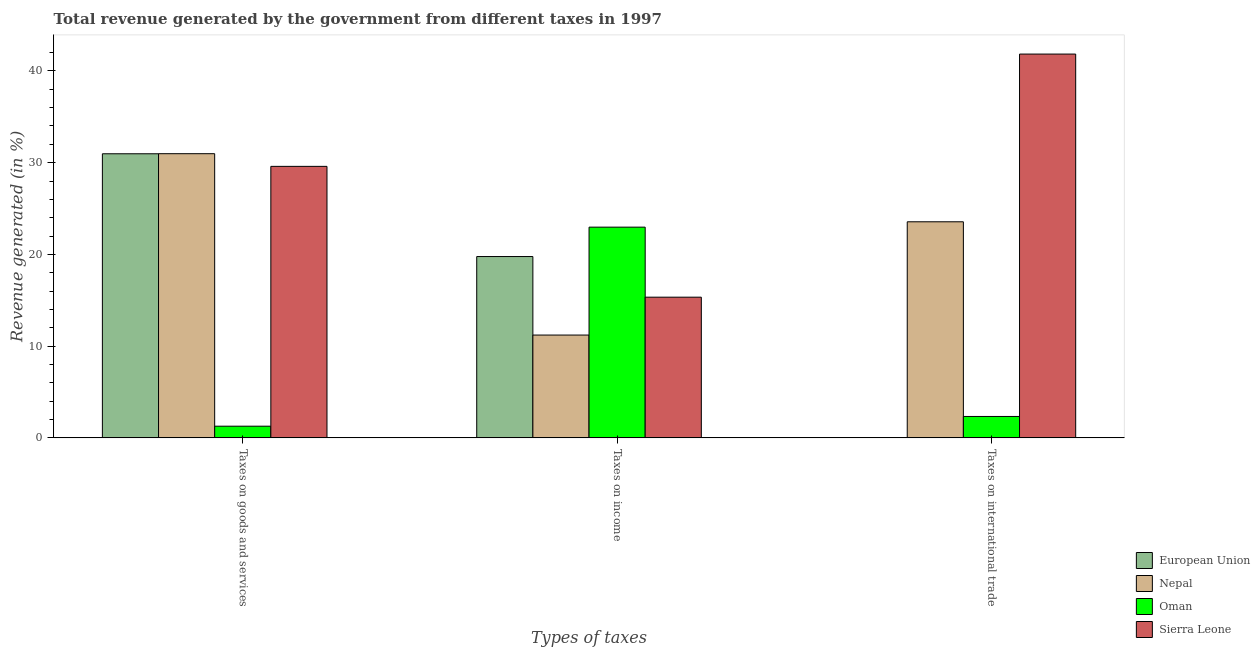How many bars are there on the 2nd tick from the left?
Keep it short and to the point. 4. What is the label of the 1st group of bars from the left?
Provide a short and direct response. Taxes on goods and services. What is the percentage of revenue generated by tax on international trade in Oman?
Make the answer very short. 2.33. Across all countries, what is the maximum percentage of revenue generated by tax on international trade?
Offer a terse response. 41.84. Across all countries, what is the minimum percentage of revenue generated by tax on international trade?
Your response must be concise. 0.02. In which country was the percentage of revenue generated by tax on international trade maximum?
Keep it short and to the point. Sierra Leone. In which country was the percentage of revenue generated by taxes on goods and services minimum?
Give a very brief answer. Oman. What is the total percentage of revenue generated by tax on international trade in the graph?
Ensure brevity in your answer.  67.74. What is the difference between the percentage of revenue generated by tax on international trade in Sierra Leone and that in Nepal?
Your response must be concise. 18.28. What is the difference between the percentage of revenue generated by taxes on income in Nepal and the percentage of revenue generated by tax on international trade in Oman?
Offer a very short reply. 8.87. What is the average percentage of revenue generated by tax on international trade per country?
Offer a very short reply. 16.94. What is the difference between the percentage of revenue generated by taxes on goods and services and percentage of revenue generated by tax on international trade in Sierra Leone?
Offer a terse response. -12.24. In how many countries, is the percentage of revenue generated by tax on international trade greater than 2 %?
Ensure brevity in your answer.  3. What is the ratio of the percentage of revenue generated by taxes on goods and services in Sierra Leone to that in Oman?
Give a very brief answer. 23.24. Is the percentage of revenue generated by taxes on income in Nepal less than that in Sierra Leone?
Provide a succinct answer. Yes. Is the difference between the percentage of revenue generated by tax on international trade in Sierra Leone and European Union greater than the difference between the percentage of revenue generated by taxes on income in Sierra Leone and European Union?
Offer a terse response. Yes. What is the difference between the highest and the second highest percentage of revenue generated by taxes on goods and services?
Offer a very short reply. 0.01. What is the difference between the highest and the lowest percentage of revenue generated by taxes on goods and services?
Keep it short and to the point. 29.7. In how many countries, is the percentage of revenue generated by taxes on goods and services greater than the average percentage of revenue generated by taxes on goods and services taken over all countries?
Your response must be concise. 3. Is the sum of the percentage of revenue generated by taxes on goods and services in Nepal and European Union greater than the maximum percentage of revenue generated by tax on international trade across all countries?
Offer a very short reply. Yes. What does the 4th bar from the left in Taxes on international trade represents?
Provide a short and direct response. Sierra Leone. What does the 1st bar from the right in Taxes on goods and services represents?
Your answer should be compact. Sierra Leone. How many bars are there?
Your response must be concise. 12. What is the difference between two consecutive major ticks on the Y-axis?
Make the answer very short. 10. Does the graph contain any zero values?
Give a very brief answer. No. Where does the legend appear in the graph?
Offer a terse response. Bottom right. How many legend labels are there?
Offer a terse response. 4. How are the legend labels stacked?
Your answer should be compact. Vertical. What is the title of the graph?
Make the answer very short. Total revenue generated by the government from different taxes in 1997. Does "Dominica" appear as one of the legend labels in the graph?
Offer a terse response. No. What is the label or title of the X-axis?
Your answer should be very brief. Types of taxes. What is the label or title of the Y-axis?
Make the answer very short. Revenue generated (in %). What is the Revenue generated (in %) in European Union in Taxes on goods and services?
Offer a terse response. 30.97. What is the Revenue generated (in %) in Nepal in Taxes on goods and services?
Offer a terse response. 30.98. What is the Revenue generated (in %) in Oman in Taxes on goods and services?
Your answer should be compact. 1.27. What is the Revenue generated (in %) of Sierra Leone in Taxes on goods and services?
Provide a succinct answer. 29.59. What is the Revenue generated (in %) in European Union in Taxes on income?
Your response must be concise. 19.77. What is the Revenue generated (in %) of Nepal in Taxes on income?
Offer a terse response. 11.21. What is the Revenue generated (in %) in Oman in Taxes on income?
Offer a terse response. 22.97. What is the Revenue generated (in %) in Sierra Leone in Taxes on income?
Ensure brevity in your answer.  15.34. What is the Revenue generated (in %) in European Union in Taxes on international trade?
Keep it short and to the point. 0.02. What is the Revenue generated (in %) in Nepal in Taxes on international trade?
Your answer should be very brief. 23.55. What is the Revenue generated (in %) in Oman in Taxes on international trade?
Your answer should be compact. 2.33. What is the Revenue generated (in %) of Sierra Leone in Taxes on international trade?
Your answer should be compact. 41.84. Across all Types of taxes, what is the maximum Revenue generated (in %) in European Union?
Your response must be concise. 30.97. Across all Types of taxes, what is the maximum Revenue generated (in %) of Nepal?
Give a very brief answer. 30.98. Across all Types of taxes, what is the maximum Revenue generated (in %) of Oman?
Give a very brief answer. 22.97. Across all Types of taxes, what is the maximum Revenue generated (in %) of Sierra Leone?
Offer a terse response. 41.84. Across all Types of taxes, what is the minimum Revenue generated (in %) of European Union?
Your answer should be very brief. 0.02. Across all Types of taxes, what is the minimum Revenue generated (in %) in Nepal?
Ensure brevity in your answer.  11.21. Across all Types of taxes, what is the minimum Revenue generated (in %) of Oman?
Ensure brevity in your answer.  1.27. Across all Types of taxes, what is the minimum Revenue generated (in %) in Sierra Leone?
Provide a succinct answer. 15.34. What is the total Revenue generated (in %) of European Union in the graph?
Make the answer very short. 50.76. What is the total Revenue generated (in %) in Nepal in the graph?
Provide a succinct answer. 65.74. What is the total Revenue generated (in %) in Oman in the graph?
Keep it short and to the point. 26.58. What is the total Revenue generated (in %) of Sierra Leone in the graph?
Your answer should be compact. 86.77. What is the difference between the Revenue generated (in %) in European Union in Taxes on goods and services and that in Taxes on income?
Offer a very short reply. 11.2. What is the difference between the Revenue generated (in %) of Nepal in Taxes on goods and services and that in Taxes on income?
Provide a succinct answer. 19.77. What is the difference between the Revenue generated (in %) of Oman in Taxes on goods and services and that in Taxes on income?
Offer a terse response. -21.7. What is the difference between the Revenue generated (in %) of Sierra Leone in Taxes on goods and services and that in Taxes on income?
Ensure brevity in your answer.  14.26. What is the difference between the Revenue generated (in %) in European Union in Taxes on goods and services and that in Taxes on international trade?
Your answer should be very brief. 30.95. What is the difference between the Revenue generated (in %) in Nepal in Taxes on goods and services and that in Taxes on international trade?
Make the answer very short. 7.42. What is the difference between the Revenue generated (in %) of Oman in Taxes on goods and services and that in Taxes on international trade?
Provide a short and direct response. -1.06. What is the difference between the Revenue generated (in %) in Sierra Leone in Taxes on goods and services and that in Taxes on international trade?
Offer a terse response. -12.24. What is the difference between the Revenue generated (in %) in European Union in Taxes on income and that in Taxes on international trade?
Your response must be concise. 19.75. What is the difference between the Revenue generated (in %) of Nepal in Taxes on income and that in Taxes on international trade?
Your answer should be compact. -12.35. What is the difference between the Revenue generated (in %) in Oman in Taxes on income and that in Taxes on international trade?
Your response must be concise. 20.64. What is the difference between the Revenue generated (in %) in Sierra Leone in Taxes on income and that in Taxes on international trade?
Your response must be concise. -26.5. What is the difference between the Revenue generated (in %) in European Union in Taxes on goods and services and the Revenue generated (in %) in Nepal in Taxes on income?
Provide a short and direct response. 19.76. What is the difference between the Revenue generated (in %) in European Union in Taxes on goods and services and the Revenue generated (in %) in Oman in Taxes on income?
Your answer should be compact. 8. What is the difference between the Revenue generated (in %) in European Union in Taxes on goods and services and the Revenue generated (in %) in Sierra Leone in Taxes on income?
Your answer should be compact. 15.63. What is the difference between the Revenue generated (in %) of Nepal in Taxes on goods and services and the Revenue generated (in %) of Oman in Taxes on income?
Keep it short and to the point. 8.01. What is the difference between the Revenue generated (in %) in Nepal in Taxes on goods and services and the Revenue generated (in %) in Sierra Leone in Taxes on income?
Provide a succinct answer. 15.64. What is the difference between the Revenue generated (in %) in Oman in Taxes on goods and services and the Revenue generated (in %) in Sierra Leone in Taxes on income?
Give a very brief answer. -14.06. What is the difference between the Revenue generated (in %) in European Union in Taxes on goods and services and the Revenue generated (in %) in Nepal in Taxes on international trade?
Your answer should be compact. 7.42. What is the difference between the Revenue generated (in %) of European Union in Taxes on goods and services and the Revenue generated (in %) of Oman in Taxes on international trade?
Provide a short and direct response. 28.64. What is the difference between the Revenue generated (in %) in European Union in Taxes on goods and services and the Revenue generated (in %) in Sierra Leone in Taxes on international trade?
Your answer should be very brief. -10.87. What is the difference between the Revenue generated (in %) of Nepal in Taxes on goods and services and the Revenue generated (in %) of Oman in Taxes on international trade?
Offer a very short reply. 28.64. What is the difference between the Revenue generated (in %) in Nepal in Taxes on goods and services and the Revenue generated (in %) in Sierra Leone in Taxes on international trade?
Provide a succinct answer. -10.86. What is the difference between the Revenue generated (in %) in Oman in Taxes on goods and services and the Revenue generated (in %) in Sierra Leone in Taxes on international trade?
Keep it short and to the point. -40.56. What is the difference between the Revenue generated (in %) in European Union in Taxes on income and the Revenue generated (in %) in Nepal in Taxes on international trade?
Your answer should be compact. -3.79. What is the difference between the Revenue generated (in %) in European Union in Taxes on income and the Revenue generated (in %) in Oman in Taxes on international trade?
Your answer should be compact. 17.43. What is the difference between the Revenue generated (in %) of European Union in Taxes on income and the Revenue generated (in %) of Sierra Leone in Taxes on international trade?
Your answer should be very brief. -22.07. What is the difference between the Revenue generated (in %) in Nepal in Taxes on income and the Revenue generated (in %) in Oman in Taxes on international trade?
Ensure brevity in your answer.  8.87. What is the difference between the Revenue generated (in %) of Nepal in Taxes on income and the Revenue generated (in %) of Sierra Leone in Taxes on international trade?
Ensure brevity in your answer.  -30.63. What is the difference between the Revenue generated (in %) of Oman in Taxes on income and the Revenue generated (in %) of Sierra Leone in Taxes on international trade?
Your answer should be very brief. -18.87. What is the average Revenue generated (in %) in European Union per Types of taxes?
Make the answer very short. 16.92. What is the average Revenue generated (in %) of Nepal per Types of taxes?
Provide a succinct answer. 21.91. What is the average Revenue generated (in %) of Oman per Types of taxes?
Make the answer very short. 8.86. What is the average Revenue generated (in %) in Sierra Leone per Types of taxes?
Provide a short and direct response. 28.92. What is the difference between the Revenue generated (in %) of European Union and Revenue generated (in %) of Nepal in Taxes on goods and services?
Offer a terse response. -0.01. What is the difference between the Revenue generated (in %) in European Union and Revenue generated (in %) in Oman in Taxes on goods and services?
Your answer should be very brief. 29.7. What is the difference between the Revenue generated (in %) of European Union and Revenue generated (in %) of Sierra Leone in Taxes on goods and services?
Your answer should be compact. 1.37. What is the difference between the Revenue generated (in %) of Nepal and Revenue generated (in %) of Oman in Taxes on goods and services?
Offer a very short reply. 29.7. What is the difference between the Revenue generated (in %) of Nepal and Revenue generated (in %) of Sierra Leone in Taxes on goods and services?
Provide a short and direct response. 1.38. What is the difference between the Revenue generated (in %) of Oman and Revenue generated (in %) of Sierra Leone in Taxes on goods and services?
Offer a very short reply. -28.32. What is the difference between the Revenue generated (in %) of European Union and Revenue generated (in %) of Nepal in Taxes on income?
Provide a succinct answer. 8.56. What is the difference between the Revenue generated (in %) of European Union and Revenue generated (in %) of Oman in Taxes on income?
Your answer should be compact. -3.2. What is the difference between the Revenue generated (in %) of European Union and Revenue generated (in %) of Sierra Leone in Taxes on income?
Provide a short and direct response. 4.43. What is the difference between the Revenue generated (in %) in Nepal and Revenue generated (in %) in Oman in Taxes on income?
Your answer should be very brief. -11.76. What is the difference between the Revenue generated (in %) in Nepal and Revenue generated (in %) in Sierra Leone in Taxes on income?
Ensure brevity in your answer.  -4.13. What is the difference between the Revenue generated (in %) of Oman and Revenue generated (in %) of Sierra Leone in Taxes on income?
Offer a terse response. 7.63. What is the difference between the Revenue generated (in %) in European Union and Revenue generated (in %) in Nepal in Taxes on international trade?
Offer a terse response. -23.53. What is the difference between the Revenue generated (in %) in European Union and Revenue generated (in %) in Oman in Taxes on international trade?
Provide a succinct answer. -2.31. What is the difference between the Revenue generated (in %) in European Union and Revenue generated (in %) in Sierra Leone in Taxes on international trade?
Your response must be concise. -41.82. What is the difference between the Revenue generated (in %) in Nepal and Revenue generated (in %) in Oman in Taxes on international trade?
Give a very brief answer. 21.22. What is the difference between the Revenue generated (in %) in Nepal and Revenue generated (in %) in Sierra Leone in Taxes on international trade?
Provide a short and direct response. -18.28. What is the difference between the Revenue generated (in %) of Oman and Revenue generated (in %) of Sierra Leone in Taxes on international trade?
Make the answer very short. -39.5. What is the ratio of the Revenue generated (in %) of European Union in Taxes on goods and services to that in Taxes on income?
Make the answer very short. 1.57. What is the ratio of the Revenue generated (in %) of Nepal in Taxes on goods and services to that in Taxes on income?
Offer a terse response. 2.76. What is the ratio of the Revenue generated (in %) of Oman in Taxes on goods and services to that in Taxes on income?
Offer a very short reply. 0.06. What is the ratio of the Revenue generated (in %) in Sierra Leone in Taxes on goods and services to that in Taxes on income?
Keep it short and to the point. 1.93. What is the ratio of the Revenue generated (in %) in European Union in Taxes on goods and services to that in Taxes on international trade?
Provide a short and direct response. 1501.85. What is the ratio of the Revenue generated (in %) of Nepal in Taxes on goods and services to that in Taxes on international trade?
Keep it short and to the point. 1.32. What is the ratio of the Revenue generated (in %) in Oman in Taxes on goods and services to that in Taxes on international trade?
Your answer should be very brief. 0.55. What is the ratio of the Revenue generated (in %) in Sierra Leone in Taxes on goods and services to that in Taxes on international trade?
Offer a very short reply. 0.71. What is the ratio of the Revenue generated (in %) of European Union in Taxes on income to that in Taxes on international trade?
Keep it short and to the point. 958.55. What is the ratio of the Revenue generated (in %) of Nepal in Taxes on income to that in Taxes on international trade?
Your answer should be very brief. 0.48. What is the ratio of the Revenue generated (in %) of Oman in Taxes on income to that in Taxes on international trade?
Ensure brevity in your answer.  9.84. What is the ratio of the Revenue generated (in %) of Sierra Leone in Taxes on income to that in Taxes on international trade?
Your response must be concise. 0.37. What is the difference between the highest and the second highest Revenue generated (in %) of European Union?
Offer a terse response. 11.2. What is the difference between the highest and the second highest Revenue generated (in %) of Nepal?
Provide a succinct answer. 7.42. What is the difference between the highest and the second highest Revenue generated (in %) of Oman?
Provide a short and direct response. 20.64. What is the difference between the highest and the second highest Revenue generated (in %) of Sierra Leone?
Give a very brief answer. 12.24. What is the difference between the highest and the lowest Revenue generated (in %) in European Union?
Offer a terse response. 30.95. What is the difference between the highest and the lowest Revenue generated (in %) in Nepal?
Make the answer very short. 19.77. What is the difference between the highest and the lowest Revenue generated (in %) in Oman?
Provide a short and direct response. 21.7. What is the difference between the highest and the lowest Revenue generated (in %) in Sierra Leone?
Your answer should be compact. 26.5. 